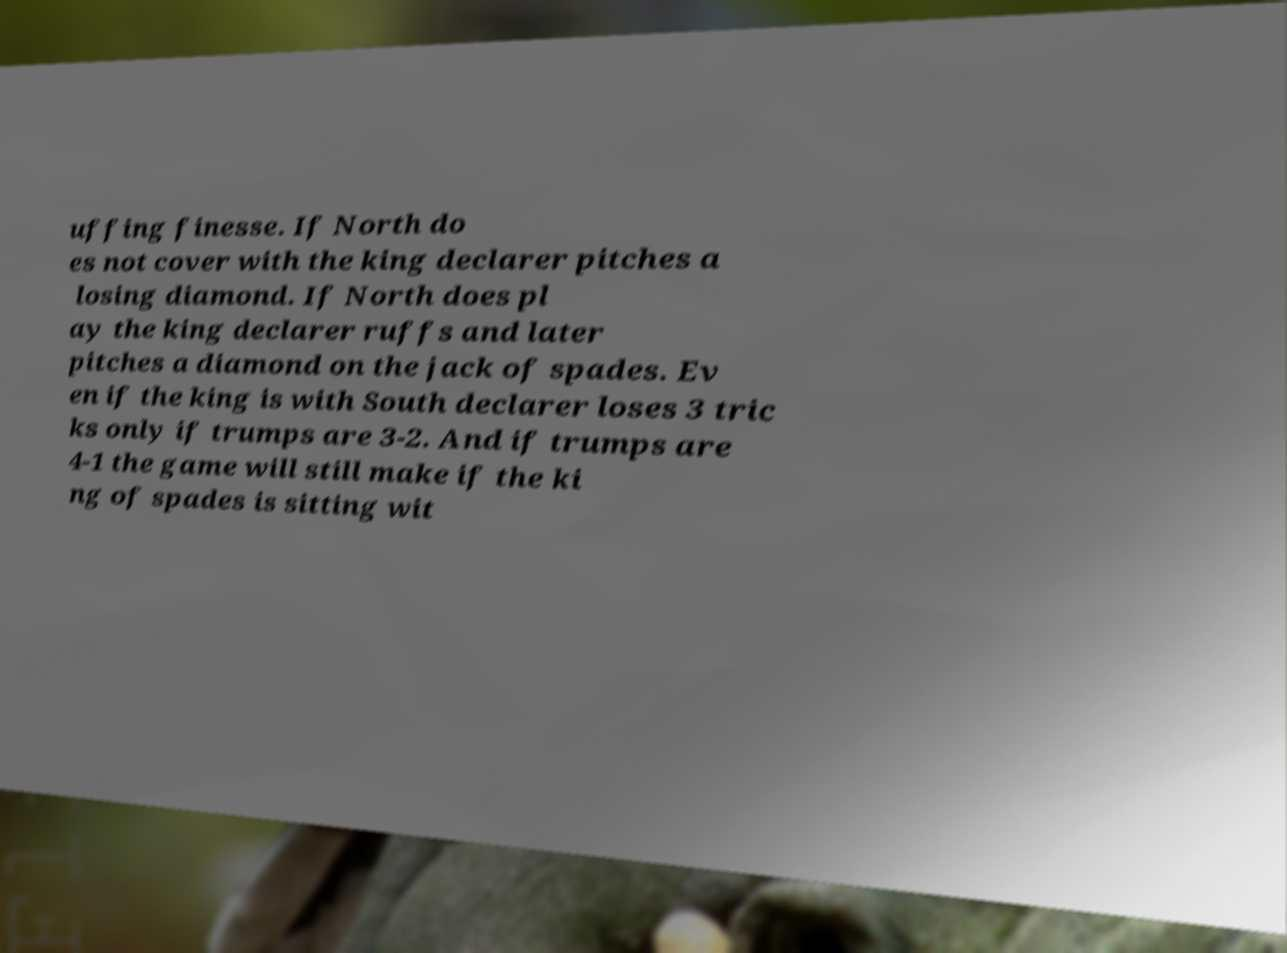Can you read and provide the text displayed in the image?This photo seems to have some interesting text. Can you extract and type it out for me? uffing finesse. If North do es not cover with the king declarer pitches a losing diamond. If North does pl ay the king declarer ruffs and later pitches a diamond on the jack of spades. Ev en if the king is with South declarer loses 3 tric ks only if trumps are 3-2. And if trumps are 4-1 the game will still make if the ki ng of spades is sitting wit 